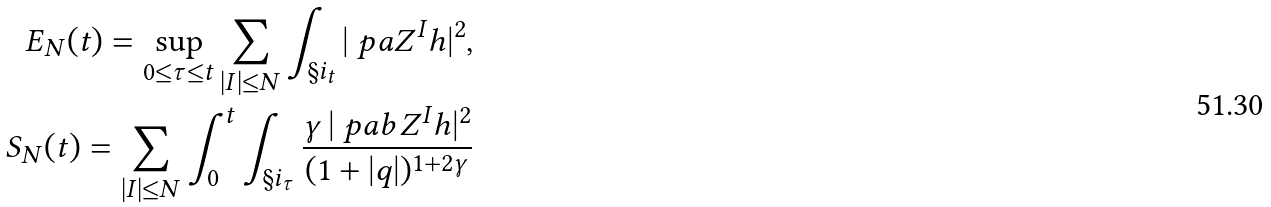<formula> <loc_0><loc_0><loc_500><loc_500>E _ { N } ( t ) = \sup _ { 0 \leq \tau \leq t } \sum _ { | I | \leq N } \int _ { \S i _ { t } } | \ p a Z ^ { I } h | ^ { 2 } , \\ S _ { N } ( t ) = \sum _ { | I | \leq N } \int _ { 0 } ^ { t } \int _ { \S i _ { \tau } } \frac { \gamma \, | \ p a b Z ^ { I } h | ^ { 2 } } { ( 1 + | q | ) ^ { 1 + 2 \gamma } }</formula> 